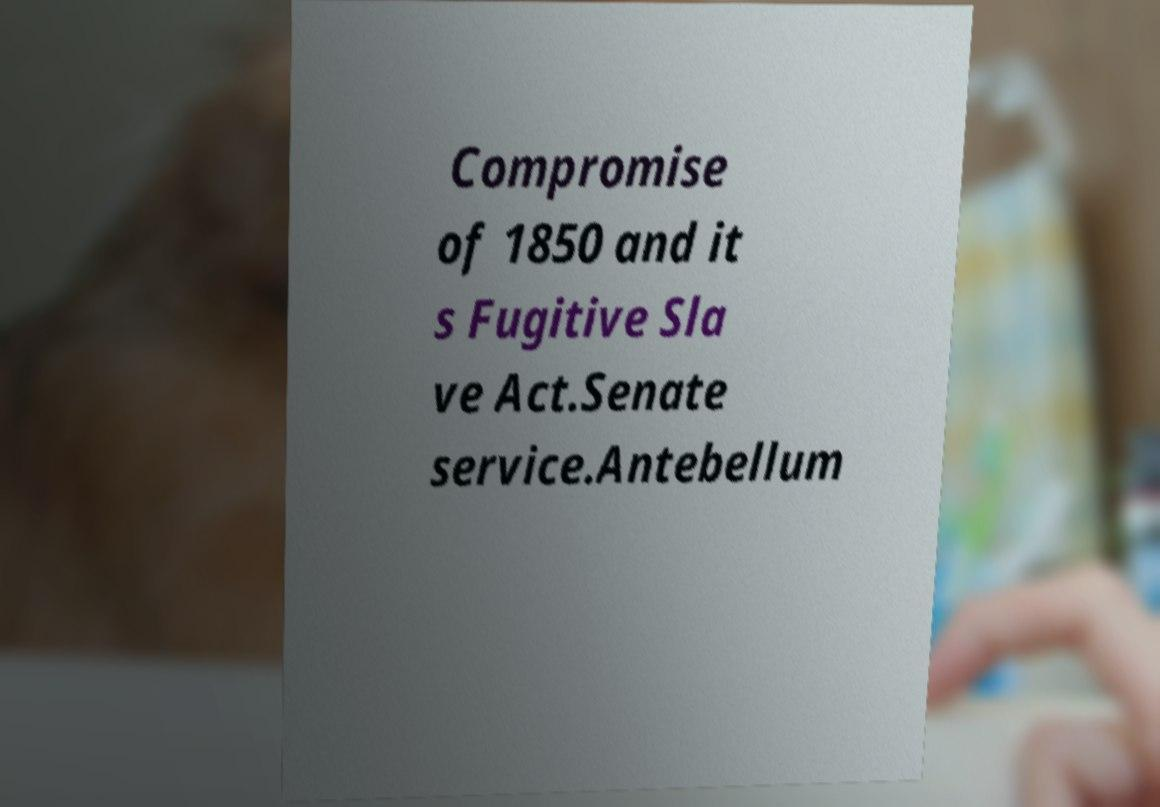Please identify and transcribe the text found in this image. Compromise of 1850 and it s Fugitive Sla ve Act.Senate service.Antebellum 